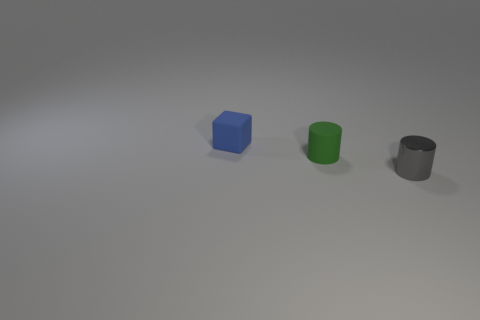What number of other things are the same material as the green cylinder?
Your answer should be compact. 1. Is the material of the tiny cylinder on the left side of the gray thing the same as the cylinder that is right of the small green object?
Provide a succinct answer. No. How many objects are both behind the gray cylinder and right of the small blue cube?
Your answer should be very brief. 1. Are there any rubber objects that have the same shape as the small gray shiny object?
Give a very brief answer. Yes. What shape is the other matte object that is the same size as the blue rubber thing?
Your answer should be compact. Cylinder. Are there the same number of tiny blue rubber things right of the matte block and tiny shiny cylinders that are behind the tiny gray shiny object?
Ensure brevity in your answer.  Yes. How big is the cylinder that is left of the tiny thing on the right side of the small green rubber cylinder?
Your answer should be very brief. Small. Is there a blue thing that has the same size as the gray cylinder?
Your answer should be compact. Yes. What is the color of the small cylinder that is the same material as the small blue cube?
Provide a short and direct response. Green. Is the number of large brown metallic cylinders less than the number of small blue blocks?
Provide a short and direct response. Yes. 